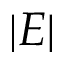<formula> <loc_0><loc_0><loc_500><loc_500>| E |</formula> 